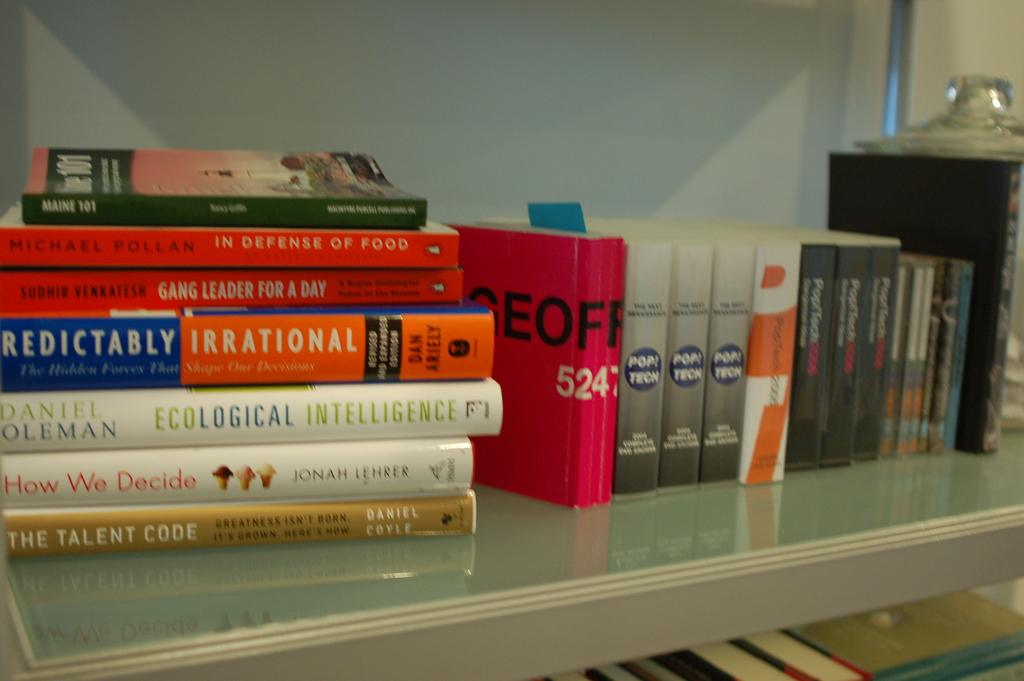<image>
Summarize the visual content of the image. A stack of books, one of which is called How We Decide. 